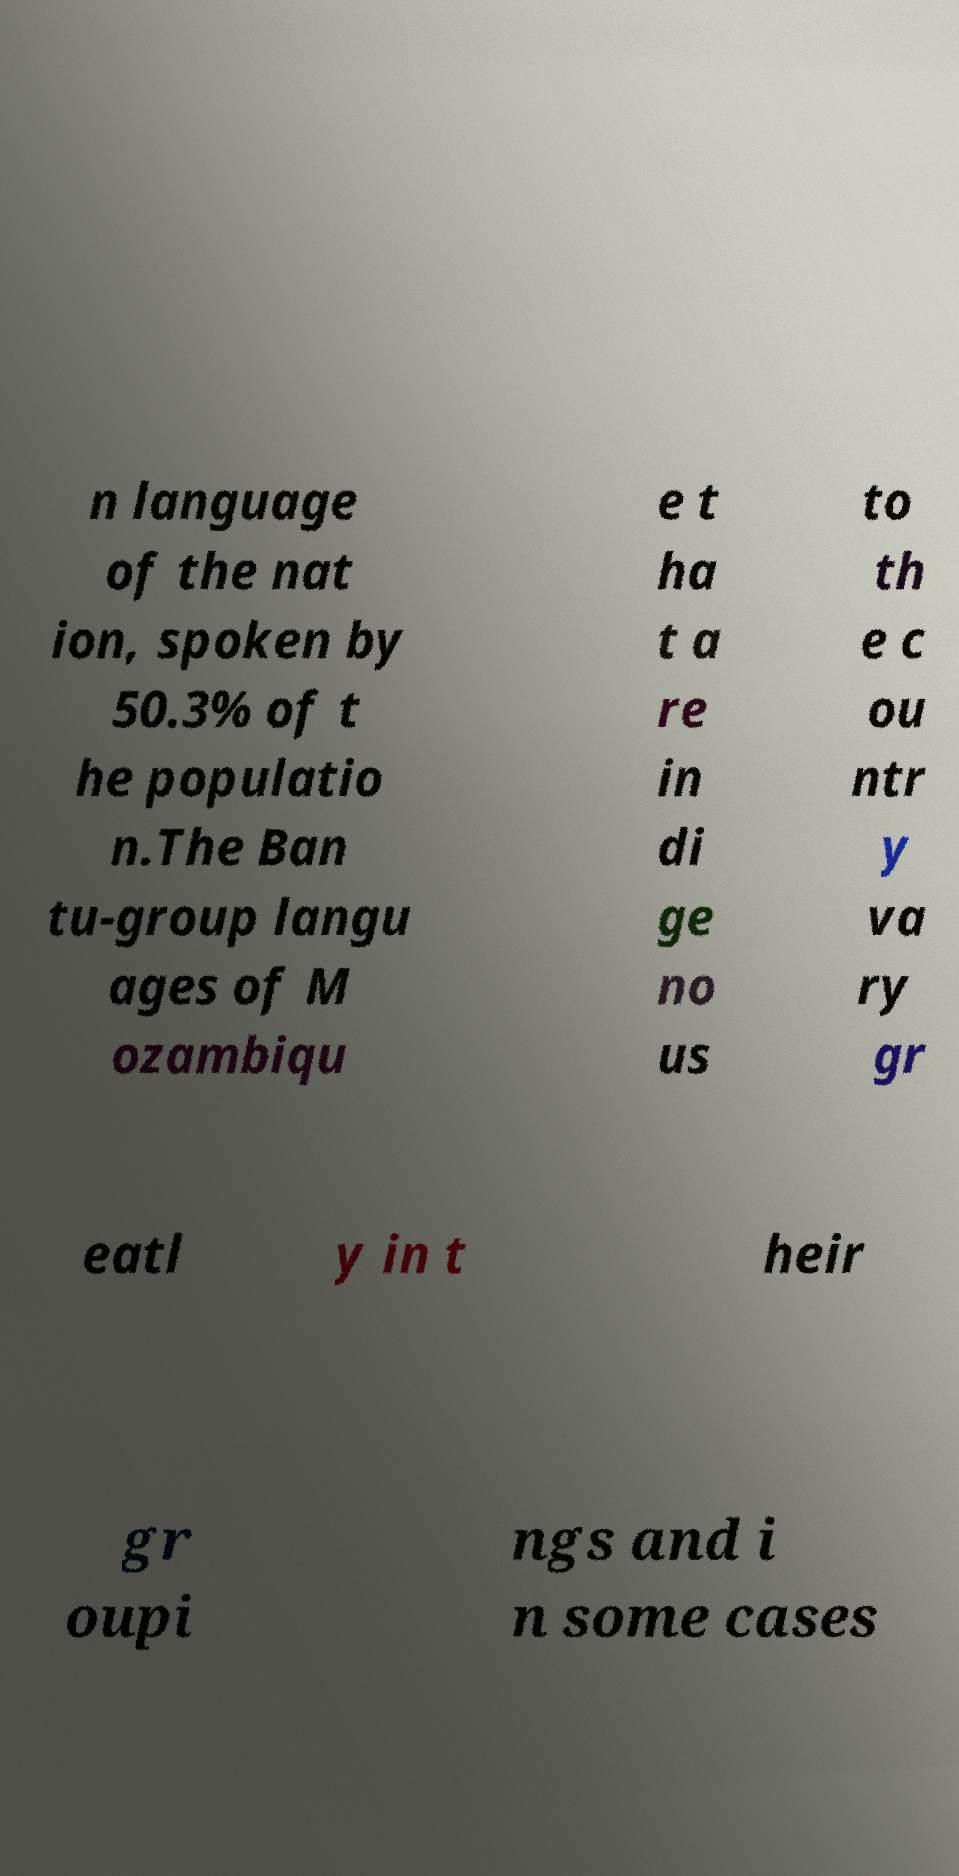What messages or text are displayed in this image? I need them in a readable, typed format. n language of the nat ion, spoken by 50.3% of t he populatio n.The Ban tu-group langu ages of M ozambiqu e t ha t a re in di ge no us to th e c ou ntr y va ry gr eatl y in t heir gr oupi ngs and i n some cases 